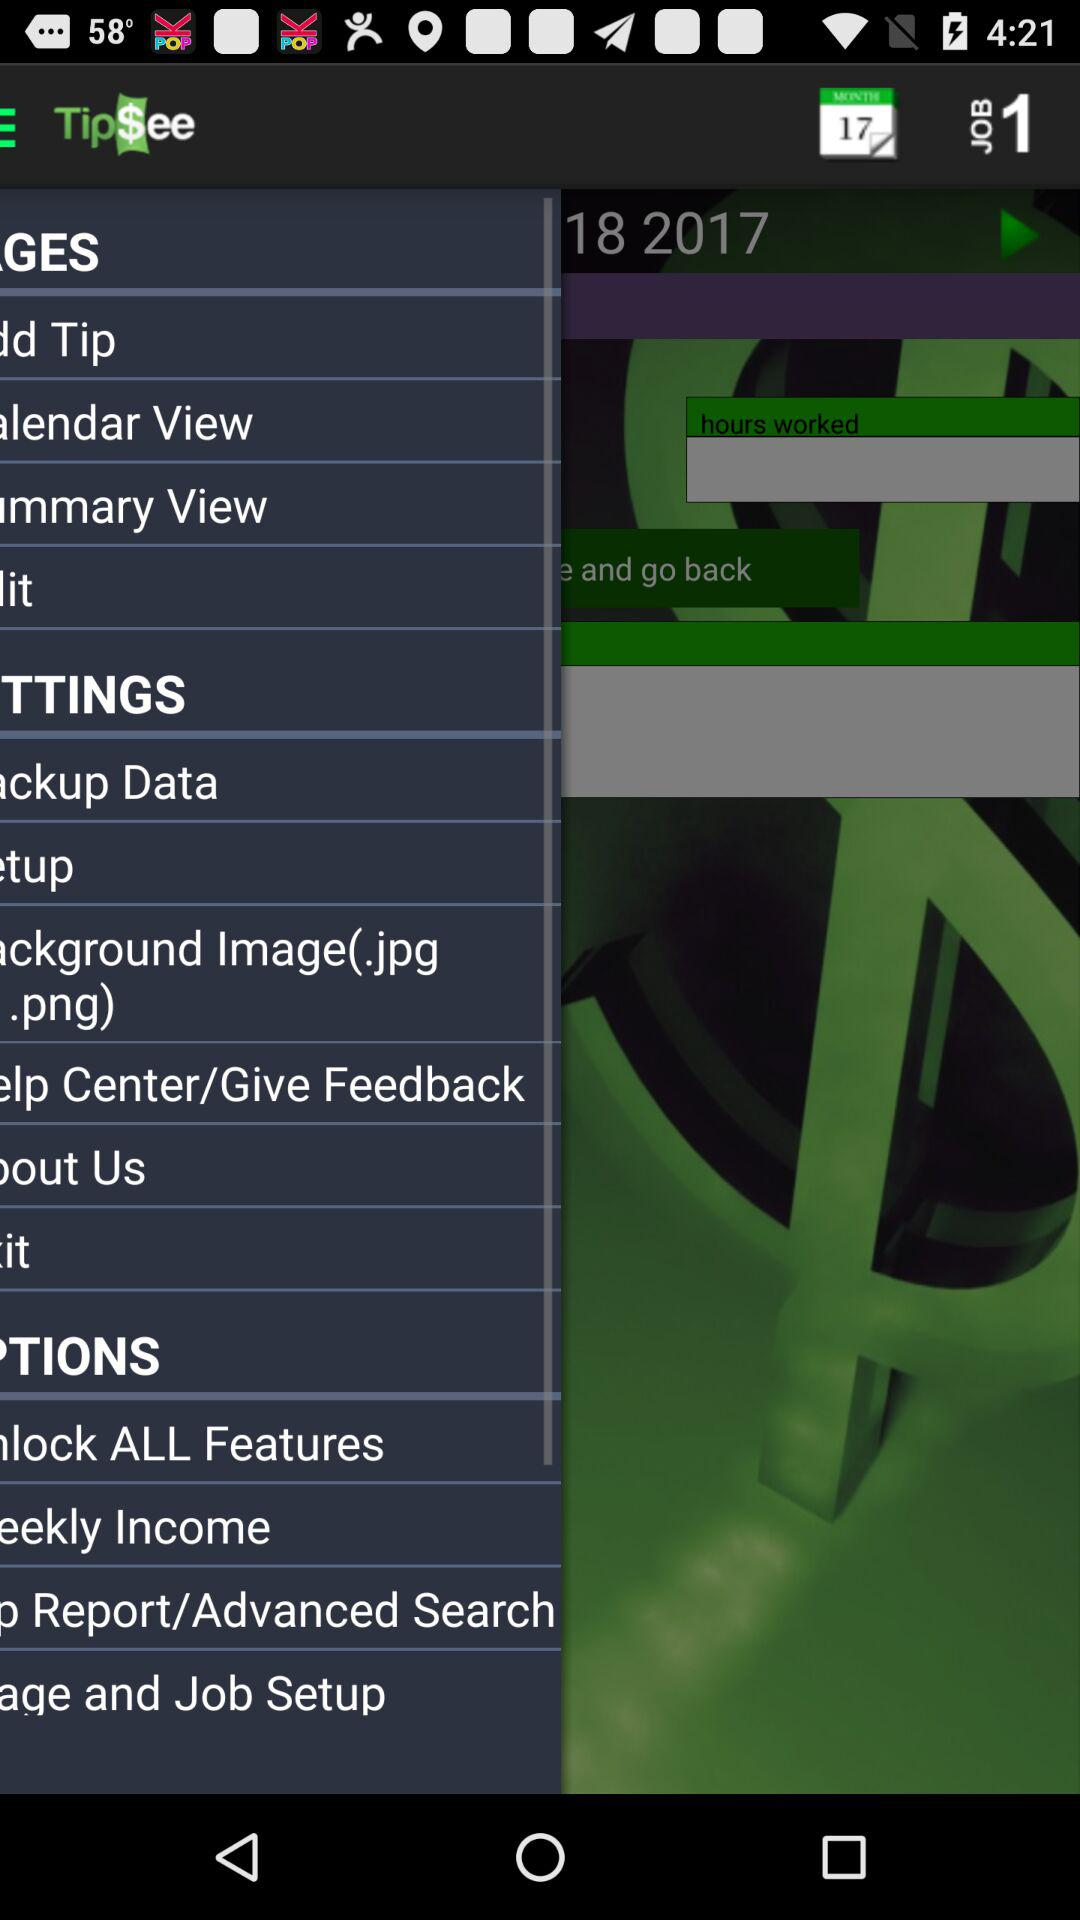What is the hourly wage for the month of February?
Answer the question using a single word or phrase. $0.00/hr 